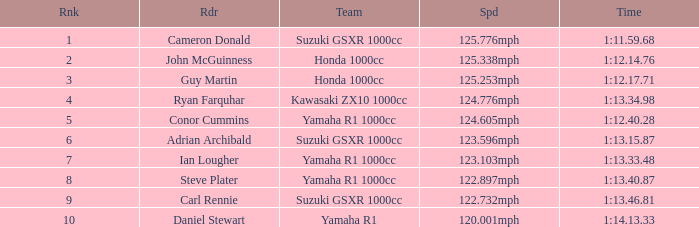What time did team kawasaki zx10 1000cc have? 1:13.34.98. 